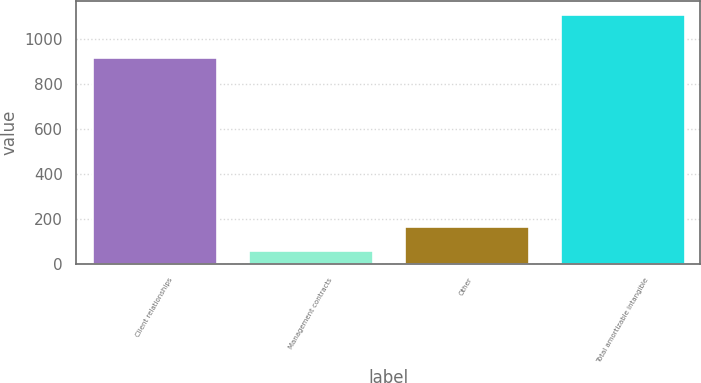Convert chart. <chart><loc_0><loc_0><loc_500><loc_500><bar_chart><fcel>Client relationships<fcel>Management contracts<fcel>Other<fcel>Total amortizable intangible<nl><fcel>920<fcel>62<fcel>167.3<fcel>1115<nl></chart> 